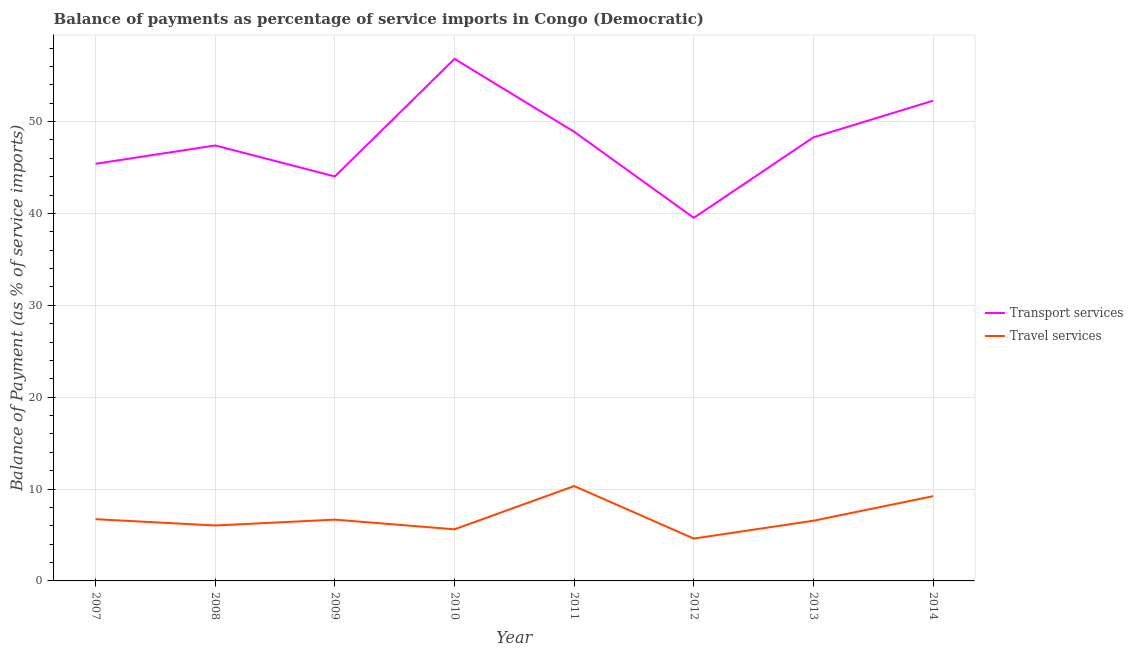How many different coloured lines are there?
Provide a short and direct response. 2. Does the line corresponding to balance of payments of travel services intersect with the line corresponding to balance of payments of transport services?
Provide a succinct answer. No. Is the number of lines equal to the number of legend labels?
Keep it short and to the point. Yes. What is the balance of payments of travel services in 2010?
Ensure brevity in your answer.  5.62. Across all years, what is the maximum balance of payments of transport services?
Make the answer very short. 56.83. Across all years, what is the minimum balance of payments of transport services?
Your response must be concise. 39.52. In which year was the balance of payments of transport services minimum?
Your answer should be compact. 2012. What is the total balance of payments of transport services in the graph?
Offer a very short reply. 382.62. What is the difference between the balance of payments of travel services in 2009 and that in 2010?
Offer a very short reply. 1.05. What is the difference between the balance of payments of transport services in 2013 and the balance of payments of travel services in 2012?
Provide a short and direct response. 43.67. What is the average balance of payments of travel services per year?
Give a very brief answer. 6.97. In the year 2013, what is the difference between the balance of payments of transport services and balance of payments of travel services?
Provide a succinct answer. 41.73. In how many years, is the balance of payments of travel services greater than 16 %?
Provide a short and direct response. 0. What is the ratio of the balance of payments of transport services in 2010 to that in 2014?
Make the answer very short. 1.09. Is the balance of payments of travel services in 2008 less than that in 2009?
Offer a terse response. Yes. Is the difference between the balance of payments of travel services in 2013 and 2014 greater than the difference between the balance of payments of transport services in 2013 and 2014?
Make the answer very short. Yes. What is the difference between the highest and the second highest balance of payments of transport services?
Make the answer very short. 4.55. What is the difference between the highest and the lowest balance of payments of travel services?
Give a very brief answer. 5.72. How many years are there in the graph?
Provide a short and direct response. 8. What is the difference between two consecutive major ticks on the Y-axis?
Offer a very short reply. 10. Are the values on the major ticks of Y-axis written in scientific E-notation?
Offer a terse response. No. Does the graph contain grids?
Your answer should be compact. Yes. Where does the legend appear in the graph?
Give a very brief answer. Center right. How many legend labels are there?
Provide a succinct answer. 2. How are the legend labels stacked?
Your answer should be compact. Vertical. What is the title of the graph?
Ensure brevity in your answer.  Balance of payments as percentage of service imports in Congo (Democratic). What is the label or title of the X-axis?
Your response must be concise. Year. What is the label or title of the Y-axis?
Offer a very short reply. Balance of Payment (as % of service imports). What is the Balance of Payment (as % of service imports) of Transport services in 2007?
Your response must be concise. 45.41. What is the Balance of Payment (as % of service imports) of Travel services in 2007?
Your answer should be very brief. 6.72. What is the Balance of Payment (as % of service imports) of Transport services in 2008?
Your answer should be compact. 47.4. What is the Balance of Payment (as % of service imports) of Travel services in 2008?
Your answer should be very brief. 6.03. What is the Balance of Payment (as % of service imports) in Transport services in 2009?
Your response must be concise. 44.03. What is the Balance of Payment (as % of service imports) in Travel services in 2009?
Your answer should be very brief. 6.67. What is the Balance of Payment (as % of service imports) in Transport services in 2010?
Your answer should be compact. 56.83. What is the Balance of Payment (as % of service imports) in Travel services in 2010?
Give a very brief answer. 5.62. What is the Balance of Payment (as % of service imports) of Transport services in 2011?
Offer a terse response. 48.89. What is the Balance of Payment (as % of service imports) of Travel services in 2011?
Offer a very short reply. 10.33. What is the Balance of Payment (as % of service imports) in Transport services in 2012?
Your answer should be very brief. 39.52. What is the Balance of Payment (as % of service imports) in Travel services in 2012?
Provide a short and direct response. 4.61. What is the Balance of Payment (as % of service imports) of Transport services in 2013?
Give a very brief answer. 48.28. What is the Balance of Payment (as % of service imports) in Travel services in 2013?
Provide a succinct answer. 6.55. What is the Balance of Payment (as % of service imports) of Transport services in 2014?
Offer a terse response. 52.27. What is the Balance of Payment (as % of service imports) in Travel services in 2014?
Ensure brevity in your answer.  9.22. Across all years, what is the maximum Balance of Payment (as % of service imports) of Transport services?
Provide a short and direct response. 56.83. Across all years, what is the maximum Balance of Payment (as % of service imports) in Travel services?
Keep it short and to the point. 10.33. Across all years, what is the minimum Balance of Payment (as % of service imports) in Transport services?
Offer a terse response. 39.52. Across all years, what is the minimum Balance of Payment (as % of service imports) in Travel services?
Provide a short and direct response. 4.61. What is the total Balance of Payment (as % of service imports) in Transport services in the graph?
Ensure brevity in your answer.  382.62. What is the total Balance of Payment (as % of service imports) in Travel services in the graph?
Offer a terse response. 55.76. What is the difference between the Balance of Payment (as % of service imports) in Transport services in 2007 and that in 2008?
Provide a succinct answer. -1.99. What is the difference between the Balance of Payment (as % of service imports) of Travel services in 2007 and that in 2008?
Provide a short and direct response. 0.69. What is the difference between the Balance of Payment (as % of service imports) of Transport services in 2007 and that in 2009?
Offer a terse response. 1.38. What is the difference between the Balance of Payment (as % of service imports) in Travel services in 2007 and that in 2009?
Offer a very short reply. 0.05. What is the difference between the Balance of Payment (as % of service imports) in Transport services in 2007 and that in 2010?
Keep it short and to the point. -11.42. What is the difference between the Balance of Payment (as % of service imports) in Travel services in 2007 and that in 2010?
Offer a very short reply. 1.1. What is the difference between the Balance of Payment (as % of service imports) of Transport services in 2007 and that in 2011?
Your answer should be compact. -3.48. What is the difference between the Balance of Payment (as % of service imports) in Travel services in 2007 and that in 2011?
Offer a very short reply. -3.61. What is the difference between the Balance of Payment (as % of service imports) in Transport services in 2007 and that in 2012?
Ensure brevity in your answer.  5.88. What is the difference between the Balance of Payment (as % of service imports) of Travel services in 2007 and that in 2012?
Provide a succinct answer. 2.11. What is the difference between the Balance of Payment (as % of service imports) in Transport services in 2007 and that in 2013?
Offer a very short reply. -2.87. What is the difference between the Balance of Payment (as % of service imports) of Travel services in 2007 and that in 2013?
Provide a short and direct response. 0.17. What is the difference between the Balance of Payment (as % of service imports) of Transport services in 2007 and that in 2014?
Offer a very short reply. -6.87. What is the difference between the Balance of Payment (as % of service imports) in Travel services in 2007 and that in 2014?
Your response must be concise. -2.5. What is the difference between the Balance of Payment (as % of service imports) in Transport services in 2008 and that in 2009?
Offer a terse response. 3.37. What is the difference between the Balance of Payment (as % of service imports) of Travel services in 2008 and that in 2009?
Ensure brevity in your answer.  -0.64. What is the difference between the Balance of Payment (as % of service imports) of Transport services in 2008 and that in 2010?
Offer a terse response. -9.43. What is the difference between the Balance of Payment (as % of service imports) in Travel services in 2008 and that in 2010?
Make the answer very short. 0.42. What is the difference between the Balance of Payment (as % of service imports) in Transport services in 2008 and that in 2011?
Keep it short and to the point. -1.49. What is the difference between the Balance of Payment (as % of service imports) of Travel services in 2008 and that in 2011?
Your answer should be compact. -4.29. What is the difference between the Balance of Payment (as % of service imports) of Transport services in 2008 and that in 2012?
Your answer should be very brief. 7.88. What is the difference between the Balance of Payment (as % of service imports) of Travel services in 2008 and that in 2012?
Give a very brief answer. 1.42. What is the difference between the Balance of Payment (as % of service imports) in Transport services in 2008 and that in 2013?
Offer a very short reply. -0.88. What is the difference between the Balance of Payment (as % of service imports) in Travel services in 2008 and that in 2013?
Offer a terse response. -0.52. What is the difference between the Balance of Payment (as % of service imports) in Transport services in 2008 and that in 2014?
Give a very brief answer. -4.87. What is the difference between the Balance of Payment (as % of service imports) in Travel services in 2008 and that in 2014?
Ensure brevity in your answer.  -3.19. What is the difference between the Balance of Payment (as % of service imports) of Transport services in 2009 and that in 2010?
Your response must be concise. -12.8. What is the difference between the Balance of Payment (as % of service imports) in Travel services in 2009 and that in 2010?
Make the answer very short. 1.05. What is the difference between the Balance of Payment (as % of service imports) of Transport services in 2009 and that in 2011?
Your answer should be very brief. -4.86. What is the difference between the Balance of Payment (as % of service imports) of Travel services in 2009 and that in 2011?
Make the answer very short. -3.66. What is the difference between the Balance of Payment (as % of service imports) of Transport services in 2009 and that in 2012?
Your answer should be very brief. 4.5. What is the difference between the Balance of Payment (as % of service imports) in Travel services in 2009 and that in 2012?
Give a very brief answer. 2.06. What is the difference between the Balance of Payment (as % of service imports) in Transport services in 2009 and that in 2013?
Make the answer very short. -4.25. What is the difference between the Balance of Payment (as % of service imports) of Travel services in 2009 and that in 2013?
Your response must be concise. 0.12. What is the difference between the Balance of Payment (as % of service imports) of Transport services in 2009 and that in 2014?
Provide a succinct answer. -8.25. What is the difference between the Balance of Payment (as % of service imports) in Travel services in 2009 and that in 2014?
Provide a succinct answer. -2.55. What is the difference between the Balance of Payment (as % of service imports) in Transport services in 2010 and that in 2011?
Offer a very short reply. 7.94. What is the difference between the Balance of Payment (as % of service imports) of Travel services in 2010 and that in 2011?
Offer a terse response. -4.71. What is the difference between the Balance of Payment (as % of service imports) of Transport services in 2010 and that in 2012?
Give a very brief answer. 17.3. What is the difference between the Balance of Payment (as % of service imports) in Travel services in 2010 and that in 2012?
Your response must be concise. 1.01. What is the difference between the Balance of Payment (as % of service imports) in Transport services in 2010 and that in 2013?
Provide a succinct answer. 8.54. What is the difference between the Balance of Payment (as % of service imports) in Travel services in 2010 and that in 2013?
Provide a succinct answer. -0.93. What is the difference between the Balance of Payment (as % of service imports) in Transport services in 2010 and that in 2014?
Keep it short and to the point. 4.55. What is the difference between the Balance of Payment (as % of service imports) of Travel services in 2010 and that in 2014?
Ensure brevity in your answer.  -3.61. What is the difference between the Balance of Payment (as % of service imports) in Transport services in 2011 and that in 2012?
Keep it short and to the point. 9.37. What is the difference between the Balance of Payment (as % of service imports) in Travel services in 2011 and that in 2012?
Provide a short and direct response. 5.72. What is the difference between the Balance of Payment (as % of service imports) in Transport services in 2011 and that in 2013?
Offer a terse response. 0.61. What is the difference between the Balance of Payment (as % of service imports) in Travel services in 2011 and that in 2013?
Your answer should be very brief. 3.77. What is the difference between the Balance of Payment (as % of service imports) in Transport services in 2011 and that in 2014?
Offer a very short reply. -3.38. What is the difference between the Balance of Payment (as % of service imports) of Travel services in 2011 and that in 2014?
Your response must be concise. 1.1. What is the difference between the Balance of Payment (as % of service imports) of Transport services in 2012 and that in 2013?
Keep it short and to the point. -8.76. What is the difference between the Balance of Payment (as % of service imports) of Travel services in 2012 and that in 2013?
Offer a very short reply. -1.94. What is the difference between the Balance of Payment (as % of service imports) in Transport services in 2012 and that in 2014?
Your response must be concise. -12.75. What is the difference between the Balance of Payment (as % of service imports) in Travel services in 2012 and that in 2014?
Your answer should be compact. -4.61. What is the difference between the Balance of Payment (as % of service imports) in Transport services in 2013 and that in 2014?
Offer a very short reply. -3.99. What is the difference between the Balance of Payment (as % of service imports) in Travel services in 2013 and that in 2014?
Keep it short and to the point. -2.67. What is the difference between the Balance of Payment (as % of service imports) in Transport services in 2007 and the Balance of Payment (as % of service imports) in Travel services in 2008?
Your response must be concise. 39.37. What is the difference between the Balance of Payment (as % of service imports) in Transport services in 2007 and the Balance of Payment (as % of service imports) in Travel services in 2009?
Your answer should be very brief. 38.74. What is the difference between the Balance of Payment (as % of service imports) in Transport services in 2007 and the Balance of Payment (as % of service imports) in Travel services in 2010?
Your answer should be very brief. 39.79. What is the difference between the Balance of Payment (as % of service imports) of Transport services in 2007 and the Balance of Payment (as % of service imports) of Travel services in 2011?
Your response must be concise. 35.08. What is the difference between the Balance of Payment (as % of service imports) of Transport services in 2007 and the Balance of Payment (as % of service imports) of Travel services in 2012?
Provide a short and direct response. 40.8. What is the difference between the Balance of Payment (as % of service imports) of Transport services in 2007 and the Balance of Payment (as % of service imports) of Travel services in 2013?
Ensure brevity in your answer.  38.85. What is the difference between the Balance of Payment (as % of service imports) in Transport services in 2007 and the Balance of Payment (as % of service imports) in Travel services in 2014?
Provide a short and direct response. 36.18. What is the difference between the Balance of Payment (as % of service imports) of Transport services in 2008 and the Balance of Payment (as % of service imports) of Travel services in 2009?
Keep it short and to the point. 40.73. What is the difference between the Balance of Payment (as % of service imports) in Transport services in 2008 and the Balance of Payment (as % of service imports) in Travel services in 2010?
Your answer should be very brief. 41.78. What is the difference between the Balance of Payment (as % of service imports) in Transport services in 2008 and the Balance of Payment (as % of service imports) in Travel services in 2011?
Give a very brief answer. 37.07. What is the difference between the Balance of Payment (as % of service imports) in Transport services in 2008 and the Balance of Payment (as % of service imports) in Travel services in 2012?
Your answer should be very brief. 42.79. What is the difference between the Balance of Payment (as % of service imports) of Transport services in 2008 and the Balance of Payment (as % of service imports) of Travel services in 2013?
Your answer should be compact. 40.85. What is the difference between the Balance of Payment (as % of service imports) in Transport services in 2008 and the Balance of Payment (as % of service imports) in Travel services in 2014?
Make the answer very short. 38.18. What is the difference between the Balance of Payment (as % of service imports) of Transport services in 2009 and the Balance of Payment (as % of service imports) of Travel services in 2010?
Offer a very short reply. 38.41. What is the difference between the Balance of Payment (as % of service imports) in Transport services in 2009 and the Balance of Payment (as % of service imports) in Travel services in 2011?
Keep it short and to the point. 33.7. What is the difference between the Balance of Payment (as % of service imports) of Transport services in 2009 and the Balance of Payment (as % of service imports) of Travel services in 2012?
Give a very brief answer. 39.42. What is the difference between the Balance of Payment (as % of service imports) in Transport services in 2009 and the Balance of Payment (as % of service imports) in Travel services in 2013?
Your answer should be compact. 37.47. What is the difference between the Balance of Payment (as % of service imports) in Transport services in 2009 and the Balance of Payment (as % of service imports) in Travel services in 2014?
Offer a very short reply. 34.8. What is the difference between the Balance of Payment (as % of service imports) in Transport services in 2010 and the Balance of Payment (as % of service imports) in Travel services in 2011?
Offer a very short reply. 46.5. What is the difference between the Balance of Payment (as % of service imports) of Transport services in 2010 and the Balance of Payment (as % of service imports) of Travel services in 2012?
Keep it short and to the point. 52.22. What is the difference between the Balance of Payment (as % of service imports) of Transport services in 2010 and the Balance of Payment (as % of service imports) of Travel services in 2013?
Make the answer very short. 50.27. What is the difference between the Balance of Payment (as % of service imports) of Transport services in 2010 and the Balance of Payment (as % of service imports) of Travel services in 2014?
Your answer should be very brief. 47.6. What is the difference between the Balance of Payment (as % of service imports) of Transport services in 2011 and the Balance of Payment (as % of service imports) of Travel services in 2012?
Keep it short and to the point. 44.28. What is the difference between the Balance of Payment (as % of service imports) of Transport services in 2011 and the Balance of Payment (as % of service imports) of Travel services in 2013?
Offer a terse response. 42.34. What is the difference between the Balance of Payment (as % of service imports) of Transport services in 2011 and the Balance of Payment (as % of service imports) of Travel services in 2014?
Offer a terse response. 39.67. What is the difference between the Balance of Payment (as % of service imports) in Transport services in 2012 and the Balance of Payment (as % of service imports) in Travel services in 2013?
Your response must be concise. 32.97. What is the difference between the Balance of Payment (as % of service imports) of Transport services in 2012 and the Balance of Payment (as % of service imports) of Travel services in 2014?
Keep it short and to the point. 30.3. What is the difference between the Balance of Payment (as % of service imports) in Transport services in 2013 and the Balance of Payment (as % of service imports) in Travel services in 2014?
Offer a very short reply. 39.06. What is the average Balance of Payment (as % of service imports) in Transport services per year?
Your answer should be very brief. 47.83. What is the average Balance of Payment (as % of service imports) in Travel services per year?
Your answer should be very brief. 6.97. In the year 2007, what is the difference between the Balance of Payment (as % of service imports) in Transport services and Balance of Payment (as % of service imports) in Travel services?
Offer a very short reply. 38.69. In the year 2008, what is the difference between the Balance of Payment (as % of service imports) in Transport services and Balance of Payment (as % of service imports) in Travel services?
Your response must be concise. 41.37. In the year 2009, what is the difference between the Balance of Payment (as % of service imports) in Transport services and Balance of Payment (as % of service imports) in Travel services?
Offer a very short reply. 37.36. In the year 2010, what is the difference between the Balance of Payment (as % of service imports) of Transport services and Balance of Payment (as % of service imports) of Travel services?
Offer a very short reply. 51.21. In the year 2011, what is the difference between the Balance of Payment (as % of service imports) of Transport services and Balance of Payment (as % of service imports) of Travel services?
Your answer should be compact. 38.56. In the year 2012, what is the difference between the Balance of Payment (as % of service imports) in Transport services and Balance of Payment (as % of service imports) in Travel services?
Ensure brevity in your answer.  34.91. In the year 2013, what is the difference between the Balance of Payment (as % of service imports) in Transport services and Balance of Payment (as % of service imports) in Travel services?
Give a very brief answer. 41.73. In the year 2014, what is the difference between the Balance of Payment (as % of service imports) in Transport services and Balance of Payment (as % of service imports) in Travel services?
Ensure brevity in your answer.  43.05. What is the ratio of the Balance of Payment (as % of service imports) of Transport services in 2007 to that in 2008?
Make the answer very short. 0.96. What is the ratio of the Balance of Payment (as % of service imports) of Travel services in 2007 to that in 2008?
Give a very brief answer. 1.11. What is the ratio of the Balance of Payment (as % of service imports) of Transport services in 2007 to that in 2009?
Give a very brief answer. 1.03. What is the ratio of the Balance of Payment (as % of service imports) in Travel services in 2007 to that in 2009?
Keep it short and to the point. 1.01. What is the ratio of the Balance of Payment (as % of service imports) in Transport services in 2007 to that in 2010?
Provide a short and direct response. 0.8. What is the ratio of the Balance of Payment (as % of service imports) of Travel services in 2007 to that in 2010?
Offer a very short reply. 1.2. What is the ratio of the Balance of Payment (as % of service imports) of Transport services in 2007 to that in 2011?
Provide a succinct answer. 0.93. What is the ratio of the Balance of Payment (as % of service imports) in Travel services in 2007 to that in 2011?
Your answer should be very brief. 0.65. What is the ratio of the Balance of Payment (as % of service imports) of Transport services in 2007 to that in 2012?
Your answer should be very brief. 1.15. What is the ratio of the Balance of Payment (as % of service imports) of Travel services in 2007 to that in 2012?
Offer a terse response. 1.46. What is the ratio of the Balance of Payment (as % of service imports) of Transport services in 2007 to that in 2013?
Keep it short and to the point. 0.94. What is the ratio of the Balance of Payment (as % of service imports) of Travel services in 2007 to that in 2013?
Give a very brief answer. 1.03. What is the ratio of the Balance of Payment (as % of service imports) in Transport services in 2007 to that in 2014?
Your answer should be very brief. 0.87. What is the ratio of the Balance of Payment (as % of service imports) in Travel services in 2007 to that in 2014?
Provide a short and direct response. 0.73. What is the ratio of the Balance of Payment (as % of service imports) of Transport services in 2008 to that in 2009?
Provide a succinct answer. 1.08. What is the ratio of the Balance of Payment (as % of service imports) of Travel services in 2008 to that in 2009?
Give a very brief answer. 0.9. What is the ratio of the Balance of Payment (as % of service imports) of Transport services in 2008 to that in 2010?
Provide a succinct answer. 0.83. What is the ratio of the Balance of Payment (as % of service imports) in Travel services in 2008 to that in 2010?
Ensure brevity in your answer.  1.07. What is the ratio of the Balance of Payment (as % of service imports) of Transport services in 2008 to that in 2011?
Your response must be concise. 0.97. What is the ratio of the Balance of Payment (as % of service imports) in Travel services in 2008 to that in 2011?
Provide a succinct answer. 0.58. What is the ratio of the Balance of Payment (as % of service imports) of Transport services in 2008 to that in 2012?
Give a very brief answer. 1.2. What is the ratio of the Balance of Payment (as % of service imports) of Travel services in 2008 to that in 2012?
Provide a succinct answer. 1.31. What is the ratio of the Balance of Payment (as % of service imports) of Transport services in 2008 to that in 2013?
Offer a terse response. 0.98. What is the ratio of the Balance of Payment (as % of service imports) of Travel services in 2008 to that in 2013?
Ensure brevity in your answer.  0.92. What is the ratio of the Balance of Payment (as % of service imports) of Transport services in 2008 to that in 2014?
Provide a short and direct response. 0.91. What is the ratio of the Balance of Payment (as % of service imports) of Travel services in 2008 to that in 2014?
Your answer should be compact. 0.65. What is the ratio of the Balance of Payment (as % of service imports) of Transport services in 2009 to that in 2010?
Ensure brevity in your answer.  0.77. What is the ratio of the Balance of Payment (as % of service imports) of Travel services in 2009 to that in 2010?
Provide a succinct answer. 1.19. What is the ratio of the Balance of Payment (as % of service imports) in Transport services in 2009 to that in 2011?
Offer a terse response. 0.9. What is the ratio of the Balance of Payment (as % of service imports) of Travel services in 2009 to that in 2011?
Provide a short and direct response. 0.65. What is the ratio of the Balance of Payment (as % of service imports) in Transport services in 2009 to that in 2012?
Your answer should be compact. 1.11. What is the ratio of the Balance of Payment (as % of service imports) of Travel services in 2009 to that in 2012?
Make the answer very short. 1.45. What is the ratio of the Balance of Payment (as % of service imports) in Transport services in 2009 to that in 2013?
Ensure brevity in your answer.  0.91. What is the ratio of the Balance of Payment (as % of service imports) of Transport services in 2009 to that in 2014?
Ensure brevity in your answer.  0.84. What is the ratio of the Balance of Payment (as % of service imports) of Travel services in 2009 to that in 2014?
Your answer should be very brief. 0.72. What is the ratio of the Balance of Payment (as % of service imports) in Transport services in 2010 to that in 2011?
Ensure brevity in your answer.  1.16. What is the ratio of the Balance of Payment (as % of service imports) of Travel services in 2010 to that in 2011?
Your answer should be very brief. 0.54. What is the ratio of the Balance of Payment (as % of service imports) of Transport services in 2010 to that in 2012?
Give a very brief answer. 1.44. What is the ratio of the Balance of Payment (as % of service imports) of Travel services in 2010 to that in 2012?
Give a very brief answer. 1.22. What is the ratio of the Balance of Payment (as % of service imports) in Transport services in 2010 to that in 2013?
Give a very brief answer. 1.18. What is the ratio of the Balance of Payment (as % of service imports) in Travel services in 2010 to that in 2013?
Offer a terse response. 0.86. What is the ratio of the Balance of Payment (as % of service imports) in Transport services in 2010 to that in 2014?
Provide a short and direct response. 1.09. What is the ratio of the Balance of Payment (as % of service imports) in Travel services in 2010 to that in 2014?
Offer a very short reply. 0.61. What is the ratio of the Balance of Payment (as % of service imports) of Transport services in 2011 to that in 2012?
Offer a very short reply. 1.24. What is the ratio of the Balance of Payment (as % of service imports) of Travel services in 2011 to that in 2012?
Give a very brief answer. 2.24. What is the ratio of the Balance of Payment (as % of service imports) in Transport services in 2011 to that in 2013?
Offer a terse response. 1.01. What is the ratio of the Balance of Payment (as % of service imports) of Travel services in 2011 to that in 2013?
Your answer should be compact. 1.58. What is the ratio of the Balance of Payment (as % of service imports) in Transport services in 2011 to that in 2014?
Give a very brief answer. 0.94. What is the ratio of the Balance of Payment (as % of service imports) of Travel services in 2011 to that in 2014?
Your answer should be compact. 1.12. What is the ratio of the Balance of Payment (as % of service imports) in Transport services in 2012 to that in 2013?
Ensure brevity in your answer.  0.82. What is the ratio of the Balance of Payment (as % of service imports) of Travel services in 2012 to that in 2013?
Ensure brevity in your answer.  0.7. What is the ratio of the Balance of Payment (as % of service imports) in Transport services in 2012 to that in 2014?
Give a very brief answer. 0.76. What is the ratio of the Balance of Payment (as % of service imports) of Travel services in 2012 to that in 2014?
Give a very brief answer. 0.5. What is the ratio of the Balance of Payment (as % of service imports) of Transport services in 2013 to that in 2014?
Give a very brief answer. 0.92. What is the ratio of the Balance of Payment (as % of service imports) in Travel services in 2013 to that in 2014?
Your answer should be very brief. 0.71. What is the difference between the highest and the second highest Balance of Payment (as % of service imports) of Transport services?
Provide a succinct answer. 4.55. What is the difference between the highest and the second highest Balance of Payment (as % of service imports) in Travel services?
Offer a very short reply. 1.1. What is the difference between the highest and the lowest Balance of Payment (as % of service imports) in Transport services?
Give a very brief answer. 17.3. What is the difference between the highest and the lowest Balance of Payment (as % of service imports) in Travel services?
Offer a terse response. 5.72. 